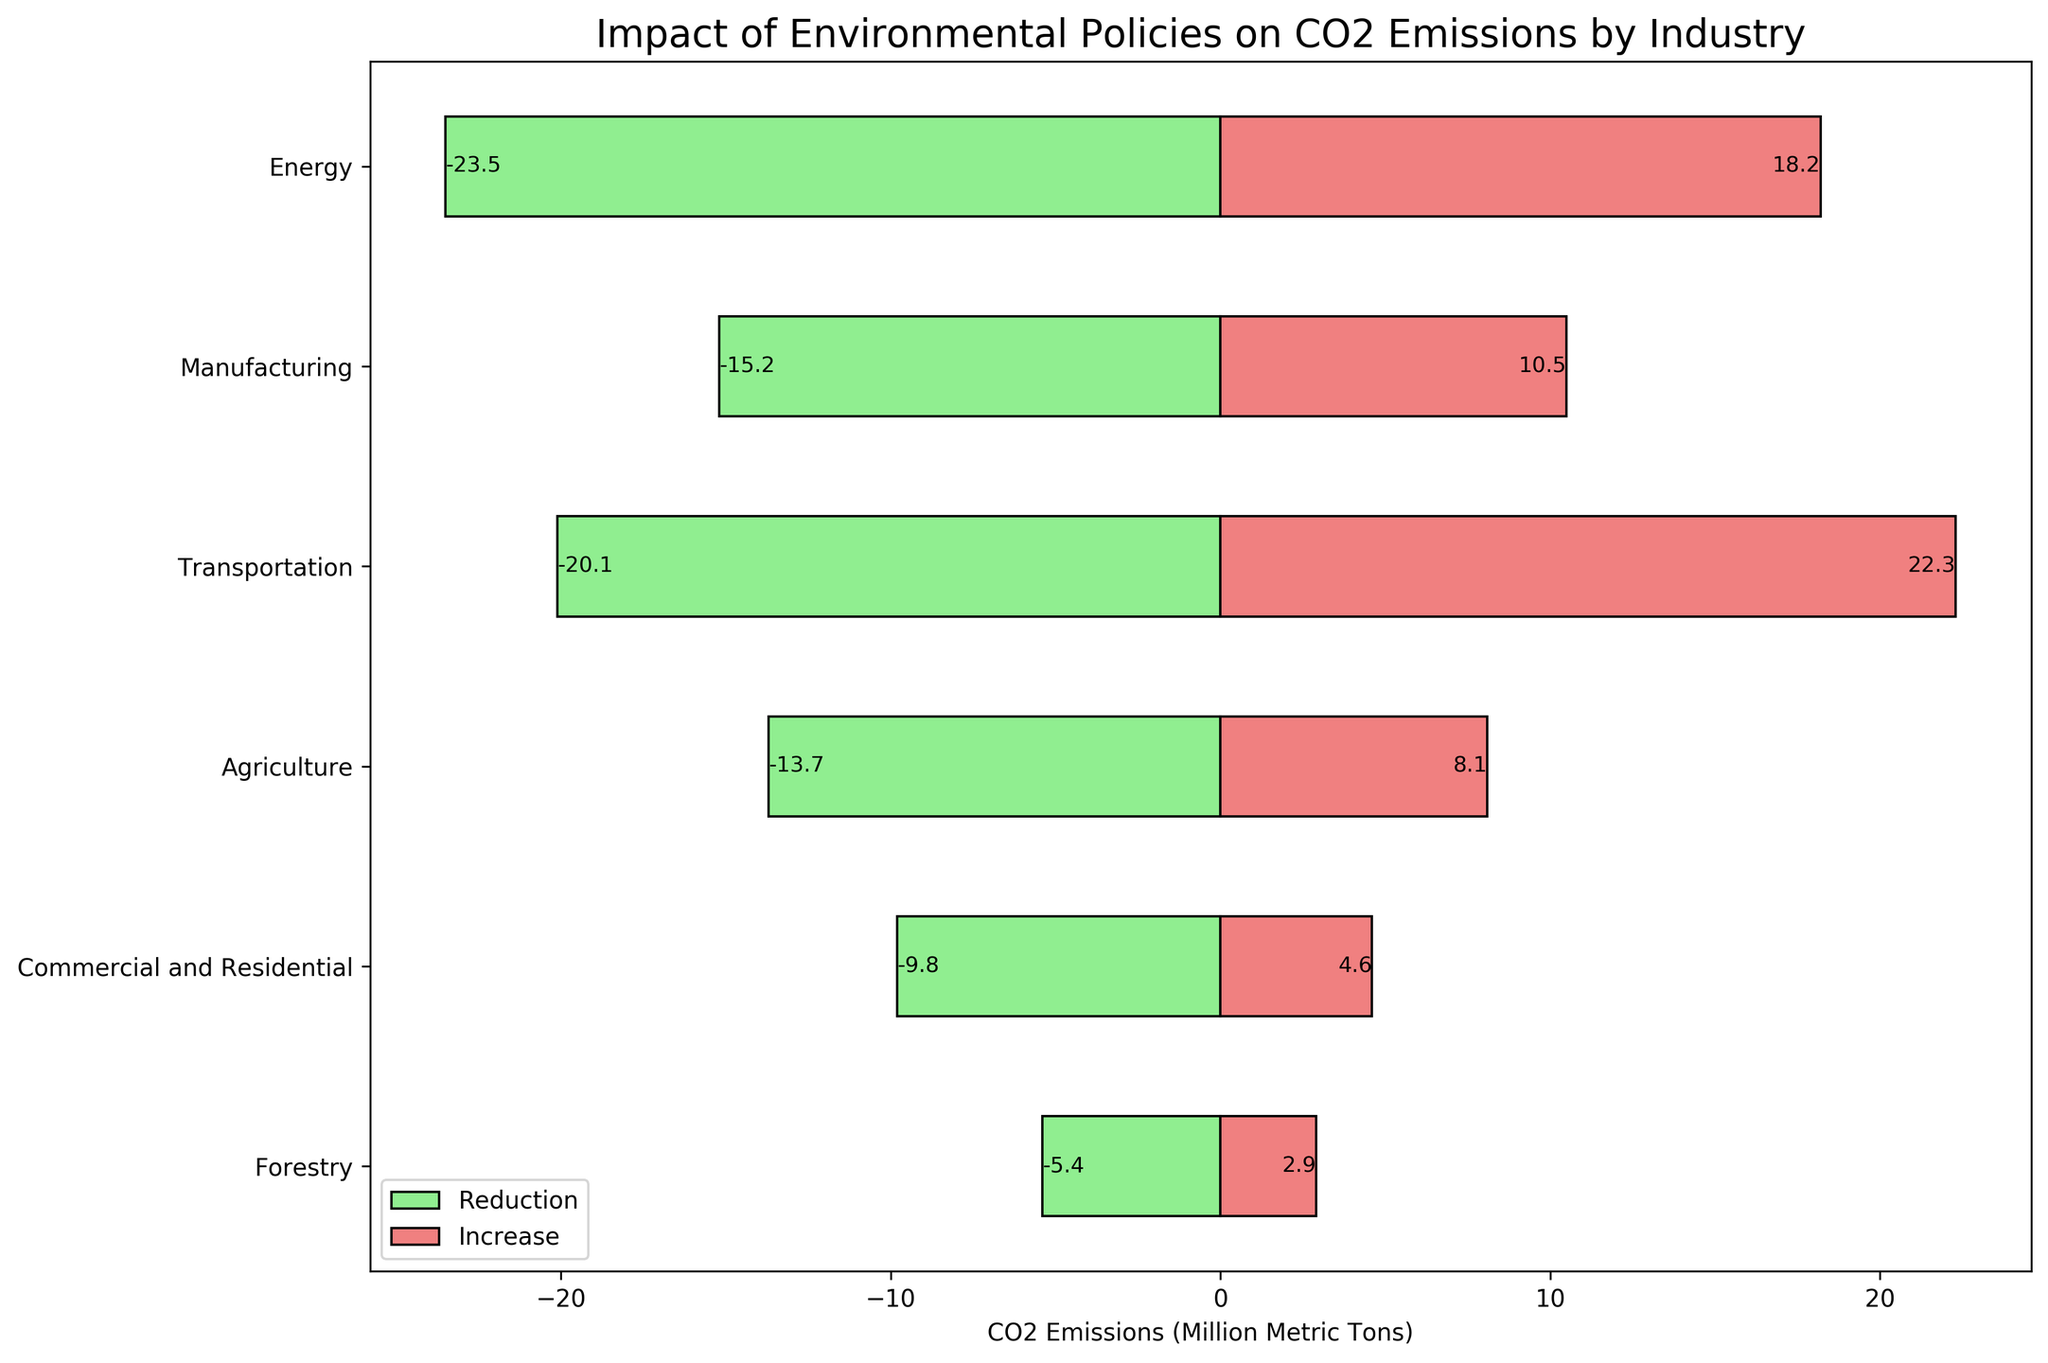What industry shows the largest reduction in CO2 emissions? The largest reduction in CO2 emissions can be identified by finding the bar with the greatest negative value. The Energy industry has the longest green bar in the negative direction for reduction, which is -23.5 million metric tons.
Answer: Energy What is the total increase in CO2 emissions caused by the Manufacturing and Transportation industries? To find the total increase, sum the increases for Manufacturing and Transportation. Manufacturing has an increase of 10.5, and Transportation has an increase of 22.3. So, the total increase is 10.5 + 22.3 = 32.8 million metric tons.
Answer: 32.8 Which industry has a higher increase in CO2 emissions, Agriculture or Commercial and Residential? Compare the lengths of the bars representing CO2 emissions increases for Agriculture and Commercial and Residential. Agriculture has an increase of 8.1 million metric tons, while Commercial and Residential has an increase of 4.6 million metric tons. Thus, Agriculture has a higher increase.
Answer: Agriculture What is the net change in CO2 emissions for the Energy industry? The net change in CO2 emissions is calculated by summing the reduction and increase values for the Energy industry. Energy has a reduction of -23.5 and an increase of 18.2. Therefore, the net change is -23.5 + 18.2 = -5.3 million metric tons.
Answer: -5.3 How does the reduction in CO2 emissions from the Transportation industry compare to its increase? Compare the bar lengths of reduction and increase for the Transportation industry. The reduction is -20.1 million metric tons, and the increase is 22.3 million metric tons. The increase is 22.3 - 20.1 = 2.2 million metric tons more than the reduction.
Answer: The increase is 2.2 more What is the average reduction in CO2 emissions across the industries mentioned? Sum the reductions and divide by the number of industries. The reductions are -23.5, -15.2, -20.1, -13.7, -9.8, and -5.4. Sum these to get -87.7 million metric tons. Divide by 6 (number of industries): -87.7 / 6 = -14.62 million metric tons.
Answer: -14.62 Which industry has the closest increase in CO2 emissions to the decrease in Manufacturing? Identify the industry whose increase in CO2 emissions is close to Manufacturing's reduction of -15.2 million metric tons. The Energy industry has an increase of 18.2, which is closest to 15.2 when compared to other industries' increases.
Answer: Energy How much more or less is the CO2 reduction in Agriculture compared to the Forestry industry? Subtract the reduction in the Forestry industry from that in Agriculture. Agriculture reduction is -13.7, Forestry reduction is -5.4. The difference is -13.7 - (-5.4) = -8.3 million metric tons.
Answer: 8.3 less 